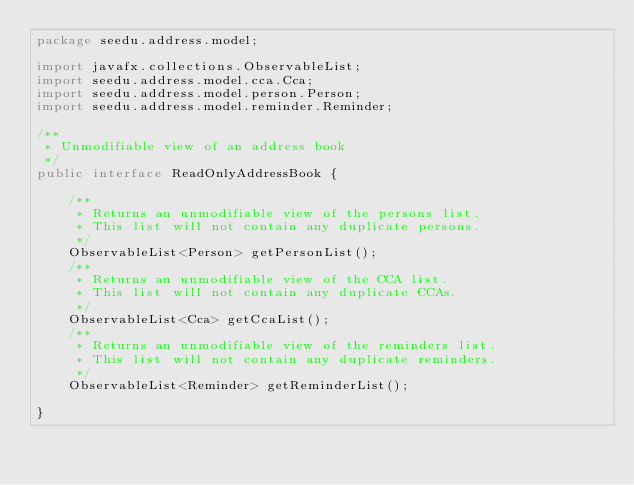<code> <loc_0><loc_0><loc_500><loc_500><_Java_>package seedu.address.model;

import javafx.collections.ObservableList;
import seedu.address.model.cca.Cca;
import seedu.address.model.person.Person;
import seedu.address.model.reminder.Reminder;

/**
 * Unmodifiable view of an address book
 */
public interface ReadOnlyAddressBook {

    /**
     * Returns an unmodifiable view of the persons list.
     * This list will not contain any duplicate persons.
     */
    ObservableList<Person> getPersonList();
    /**
     * Returns an unmodifiable view of the CCA list.
     * This list will not contain any duplicate CCAs.
     */
    ObservableList<Cca> getCcaList();
    /**
     * Returns an unmodifiable view of the reminders list.
     * This list will not contain any duplicate reminders.
     */
    ObservableList<Reminder> getReminderList();

}
</code> 